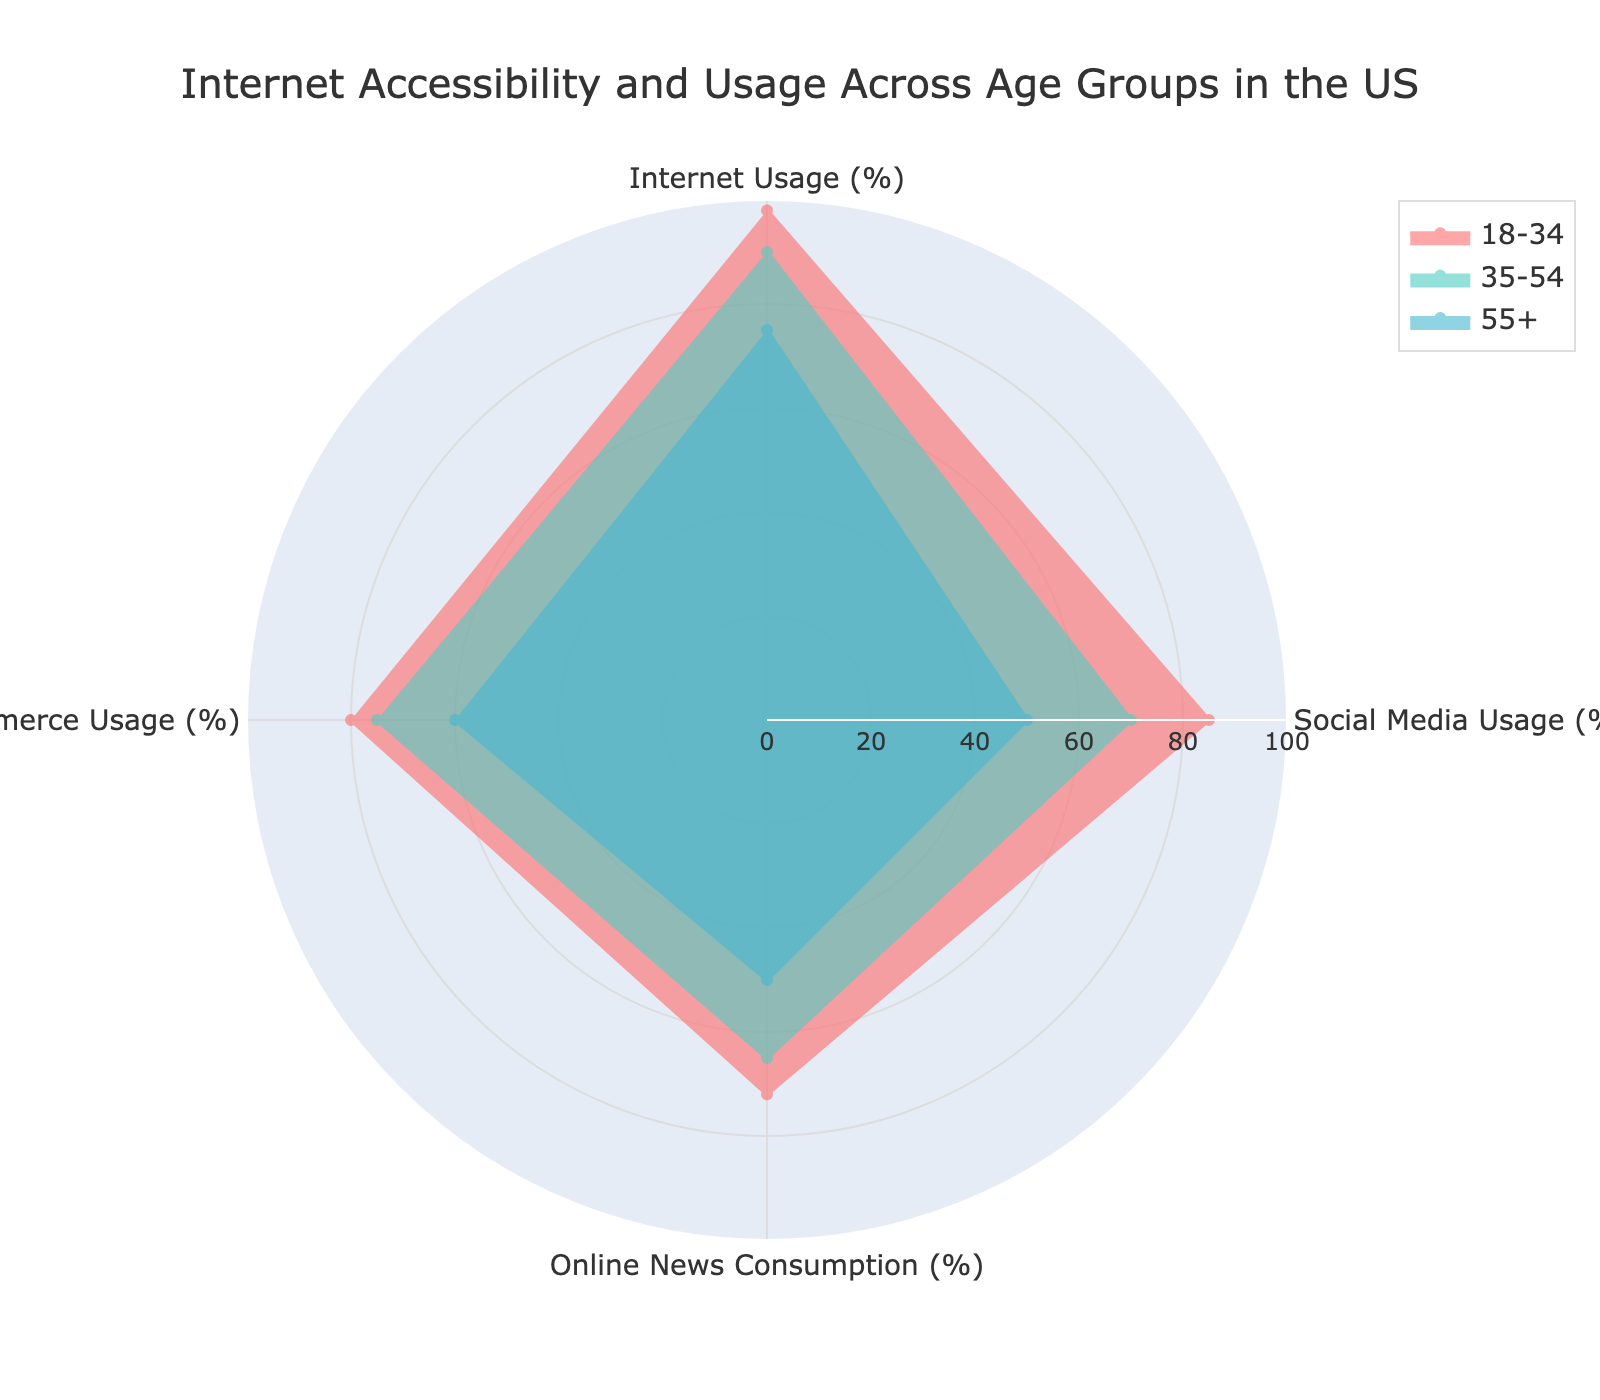What is the title of the radar chart? The title is displayed at the top of the radar chart. It reads "Internet Accessibility and Usage Across Age Groups in the US".
Answer: Internet Accessibility and Usage Across Age Groups in the US How many different age groups are presented in the chart? The chart shows three different colored areas representing distinct age groups.
Answer: Three Which age group has the highest percentage of internet usage? Looking at the data points for Internet Usage (%) on the radar chart, the age group 18-34 has the highest value at 98%.
Answer: 18-34 In which category do age groups 35-54 and 55+ have an equal percentage? By examining the radar chart, ages 35-54 and 55+ share the same value for Online News Consumption (%), both at 50%.
Answer: Online News Consumption (%) What is the difference in social media usage between age groups 18-34 and 55+? According to the radar chart, social media usage for 18-34 is 85% and for 55+ it is 50%. The difference is calculated as 85% - 50% = 35%.
Answer: 35% Identify the age group with the lowest e-commerce usage and state the percentage. By examining the data on the radar chart, the age group 55+ has the lowest e-commerce usage recorded at 60%.
Answer: 55+, 60% Which age group shows the steepest decline from internet usage to social media usage? The age group 18-34 declines from 98% internet usage to 85% social media usage, a drop of 13%. The age group 35-54 declines from 90% to 70%, a drop of 20%. The age group 55+ declines from 75% to 50%, a drop of 25%. The steepest decline is thus for the 55+ age group.
Answer: 55+ Which age group has the most balanced (smallest range) across all categories? To find this, calculate the range (maximum - minimum) for each age group across all categories. The ranges are as follows:
- 18-34: max(98, 85, 72, 80) - min(98, 85, 72, 80) = 98 - 72 = 26
- 35-54: max(90, 70, 65, 75) - min(90, 70, 65, 75) = 90 - 65 = 25
- 55+: max(75, 50, 50, 60) - min(75, 50, 50, 60) = 75 - 50 = 25
Both 35-54 and 55+ have the smallest range of 25.
Answer: 35-54 and 55+ Which usage category has the most significant drop in percentage from the age group 18-34 to 55+? Calculate the drop for each category:
- Internet Usage: 98% - 75% = 23%
- Social Media Usage: 85% - 50% = 35%
- Online News Consumption: 72% - 50% = 22%
- E-commerce Usage: 80% - 60% = 20%
The largest drop is in Social Media Usage with a 35% difference.
Answer: Social Media Usage 